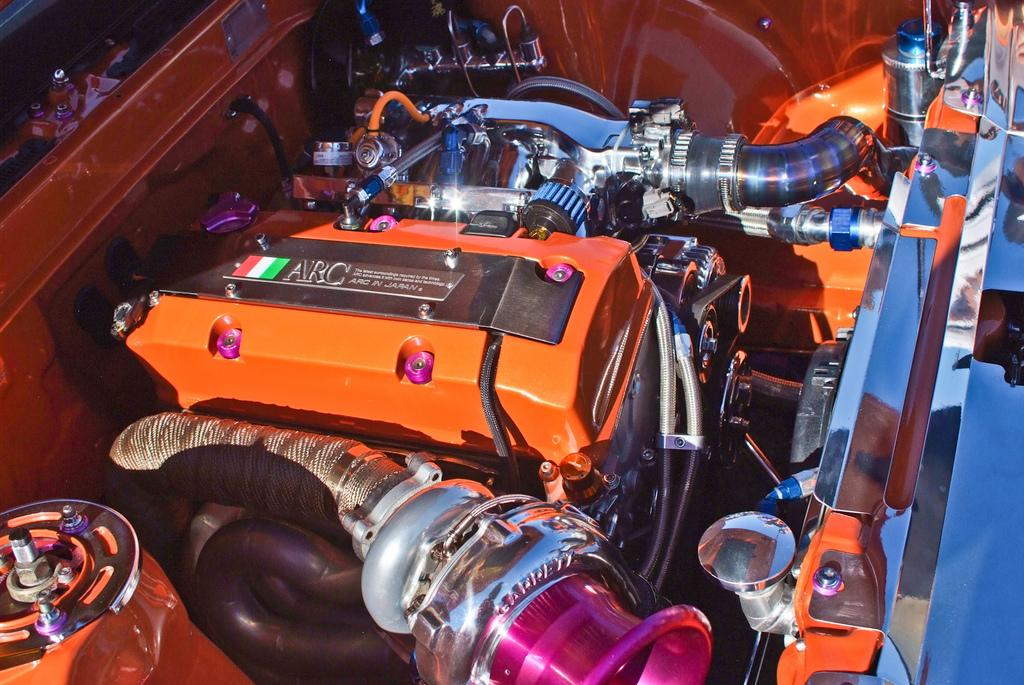What is the main subject of the image? The main subject of the image is an inside view of a car's bonnet. What type of bears can be seen polishing the car's bonnet in the image? There are no bears present in the image, and the car's bonnet is not being polished. 